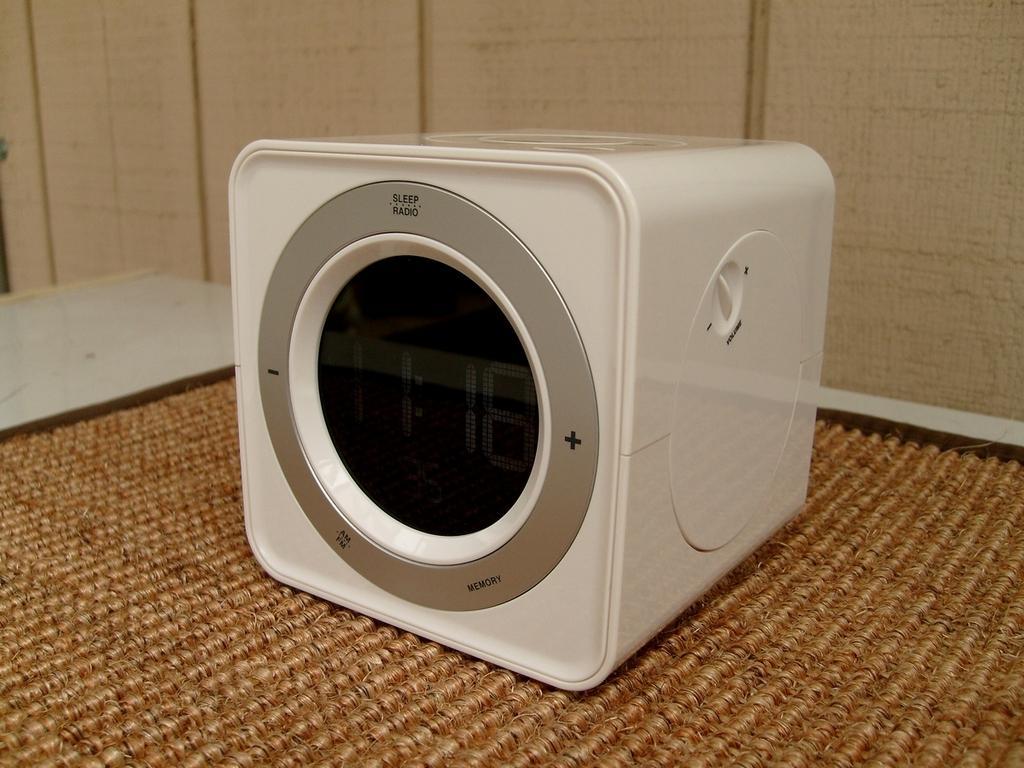Describe this image in one or two sentences. In this image there is a mat, on that mat there is a digital clock, in the background there is a wall. 